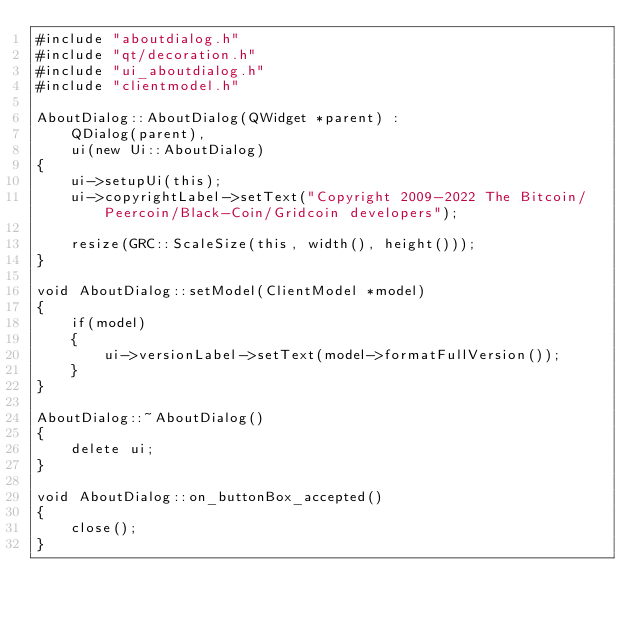<code> <loc_0><loc_0><loc_500><loc_500><_C++_>#include "aboutdialog.h"
#include "qt/decoration.h"
#include "ui_aboutdialog.h"
#include "clientmodel.h"

AboutDialog::AboutDialog(QWidget *parent) :
    QDialog(parent),
    ui(new Ui::AboutDialog)
{
    ui->setupUi(this);
    ui->copyrightLabel->setText("Copyright 2009-2022 The Bitcoin/Peercoin/Black-Coin/Gridcoin developers");

    resize(GRC::ScaleSize(this, width(), height()));
}

void AboutDialog::setModel(ClientModel *model)
{
    if(model)
    {
        ui->versionLabel->setText(model->formatFullVersion());
    }
}

AboutDialog::~AboutDialog()
{
    delete ui;
}

void AboutDialog::on_buttonBox_accepted()
{
    close();
}
</code> 